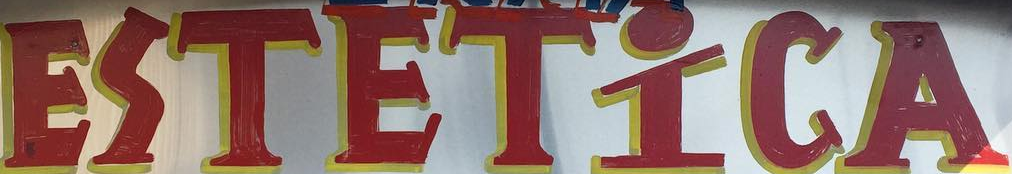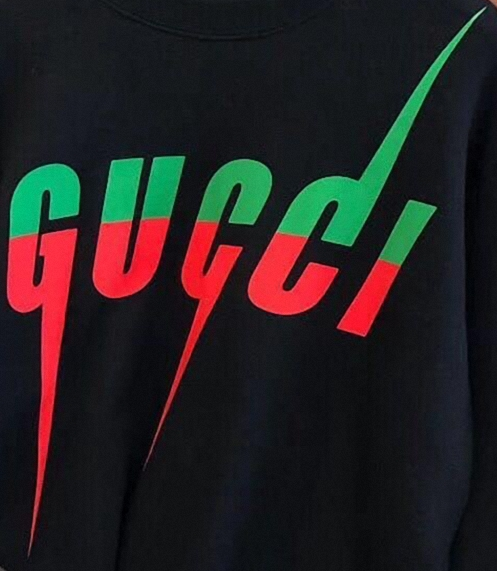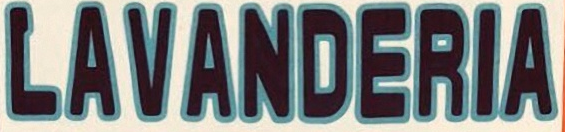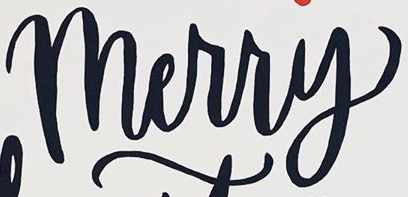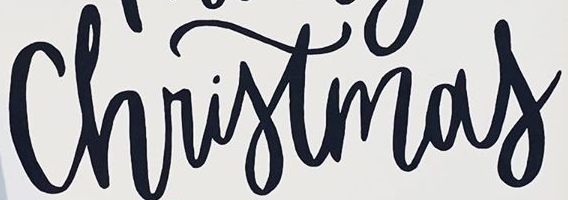Identify the words shown in these images in order, separated by a semicolon. ESTETİCA; GUCCI; LAVANDERIA; Merry; Christmas 